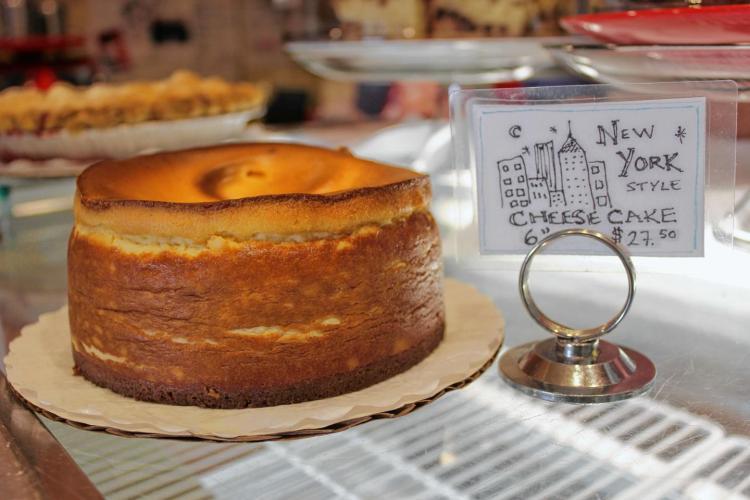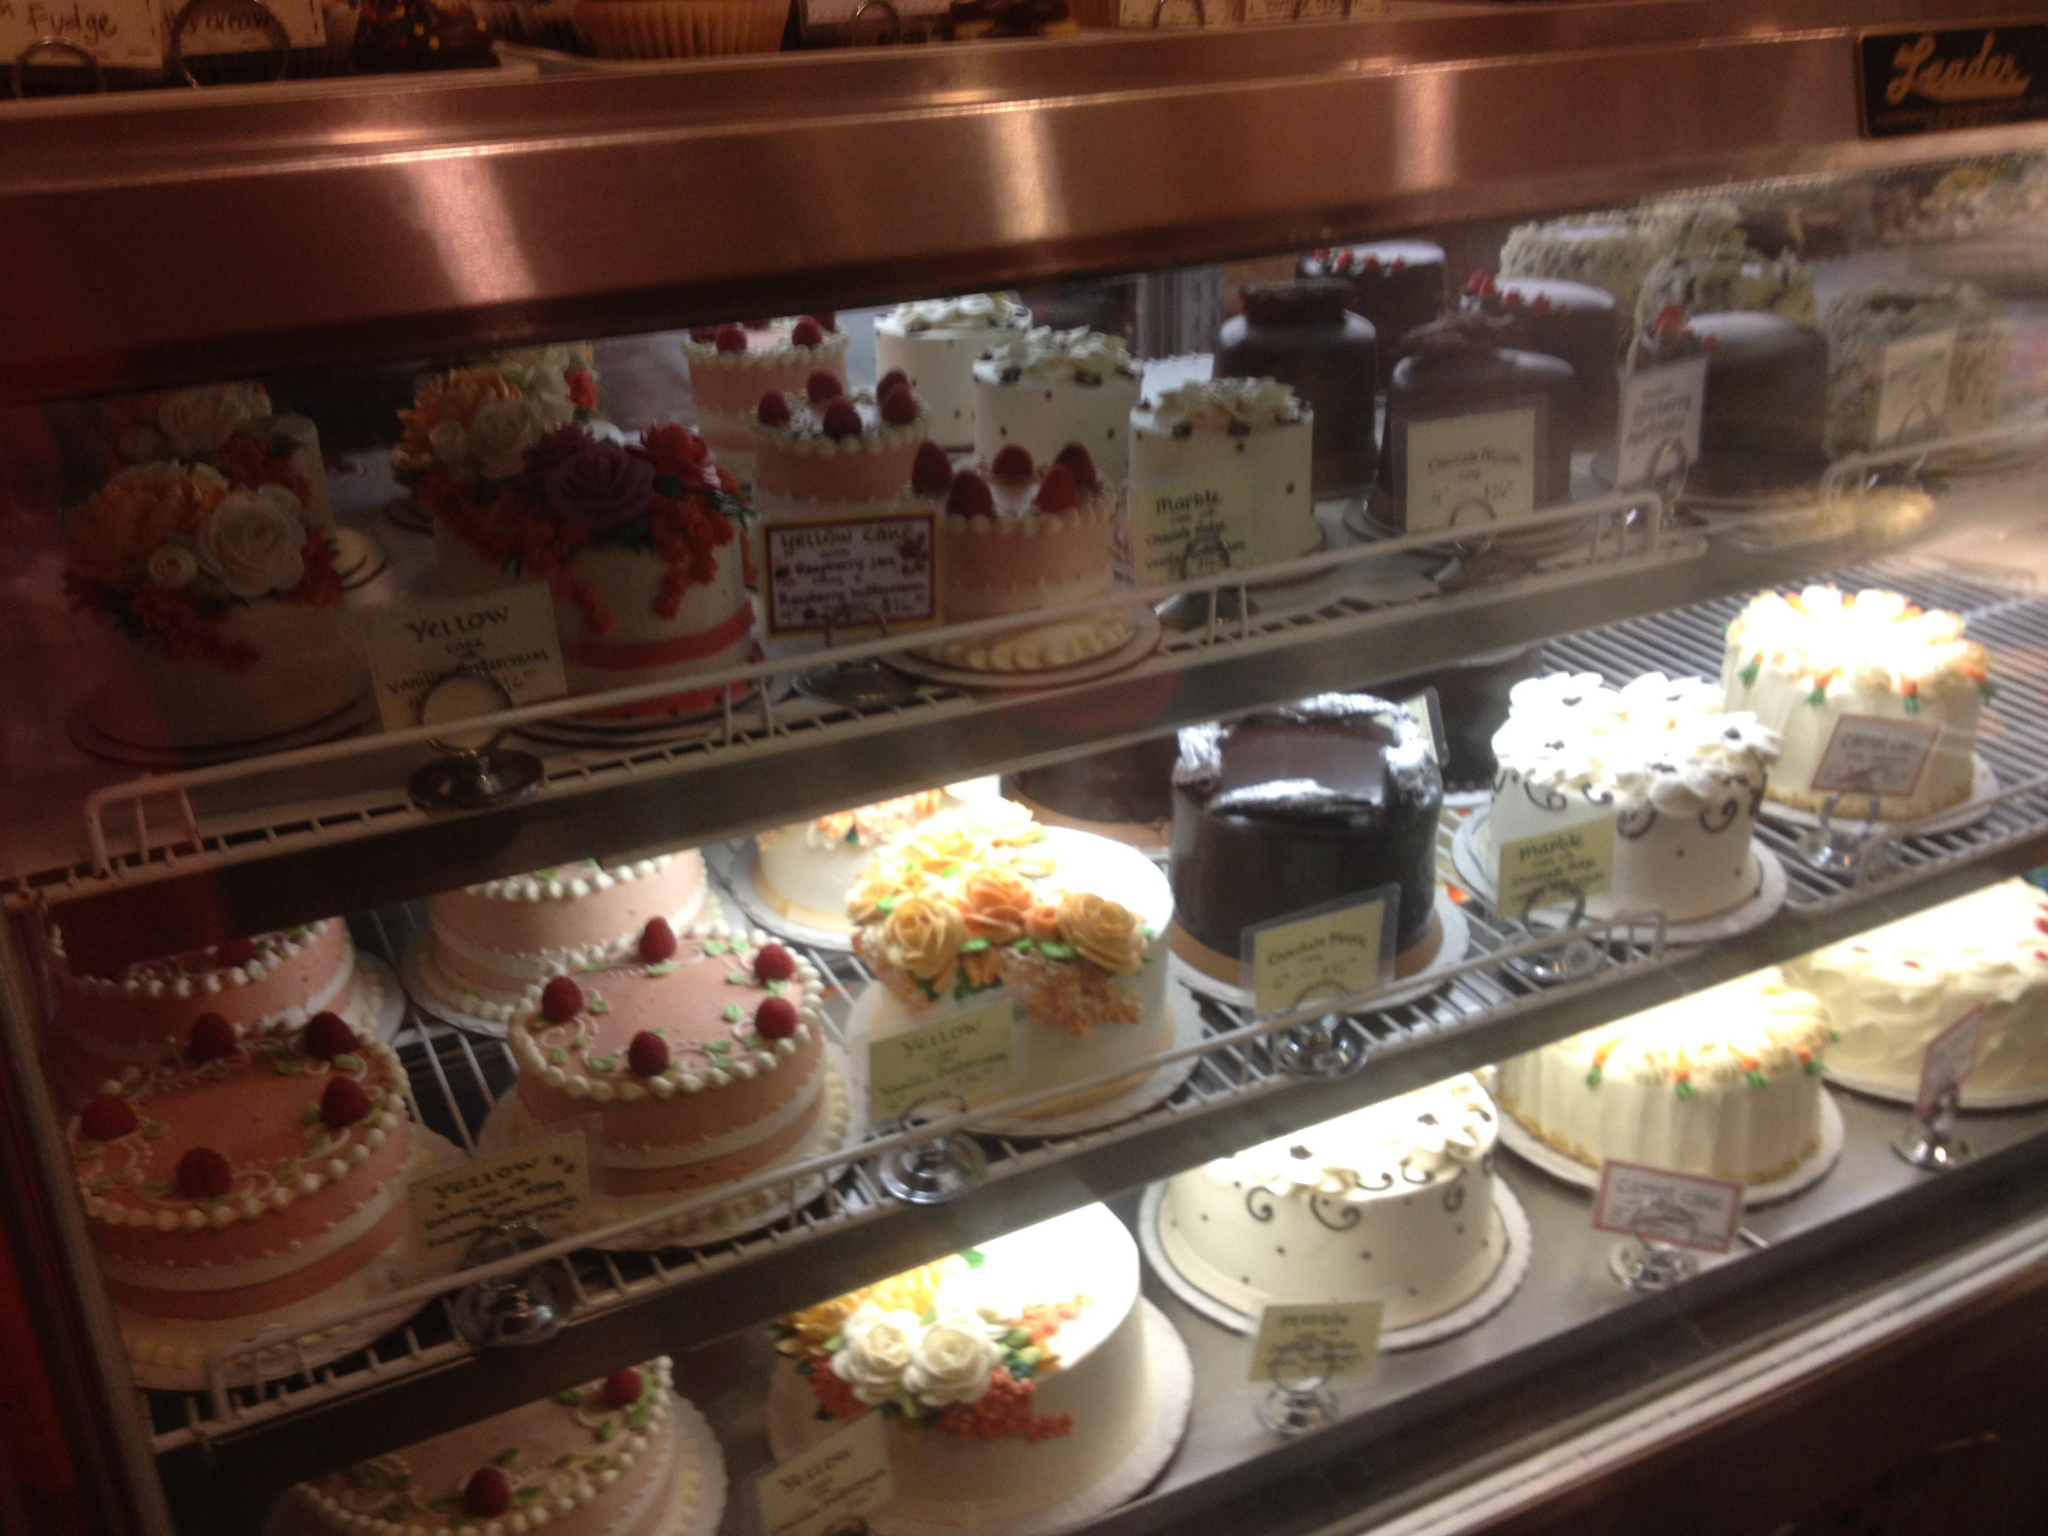The first image is the image on the left, the second image is the image on the right. For the images shown, is this caption "A row of clear lidded canisters holding baked treats is on a chrome-edged shelf in a bakery." true? Answer yes or no. No. 